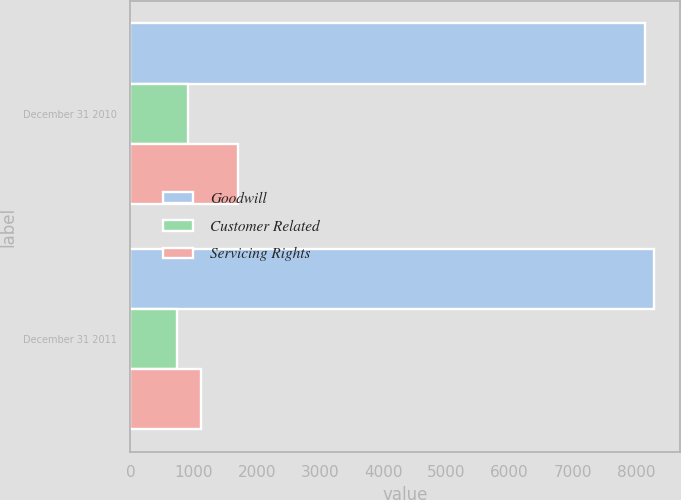Convert chart to OTSL. <chart><loc_0><loc_0><loc_500><loc_500><stacked_bar_chart><ecel><fcel>December 31 2010<fcel>December 31 2011<nl><fcel>Goodwill<fcel>8149<fcel>8285<nl><fcel>Customer Related<fcel>903<fcel>742<nl><fcel>Servicing Rights<fcel>1701<fcel>1117<nl></chart> 